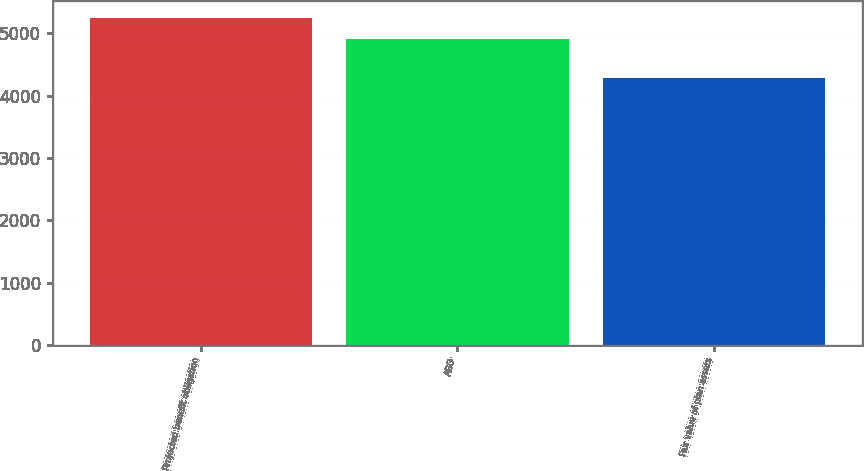Convert chart. <chart><loc_0><loc_0><loc_500><loc_500><bar_chart><fcel>Projected benefit obligation<fcel>ABO<fcel>Fair value of plan assets<nl><fcel>5252.5<fcel>4914.8<fcel>4285.2<nl></chart> 